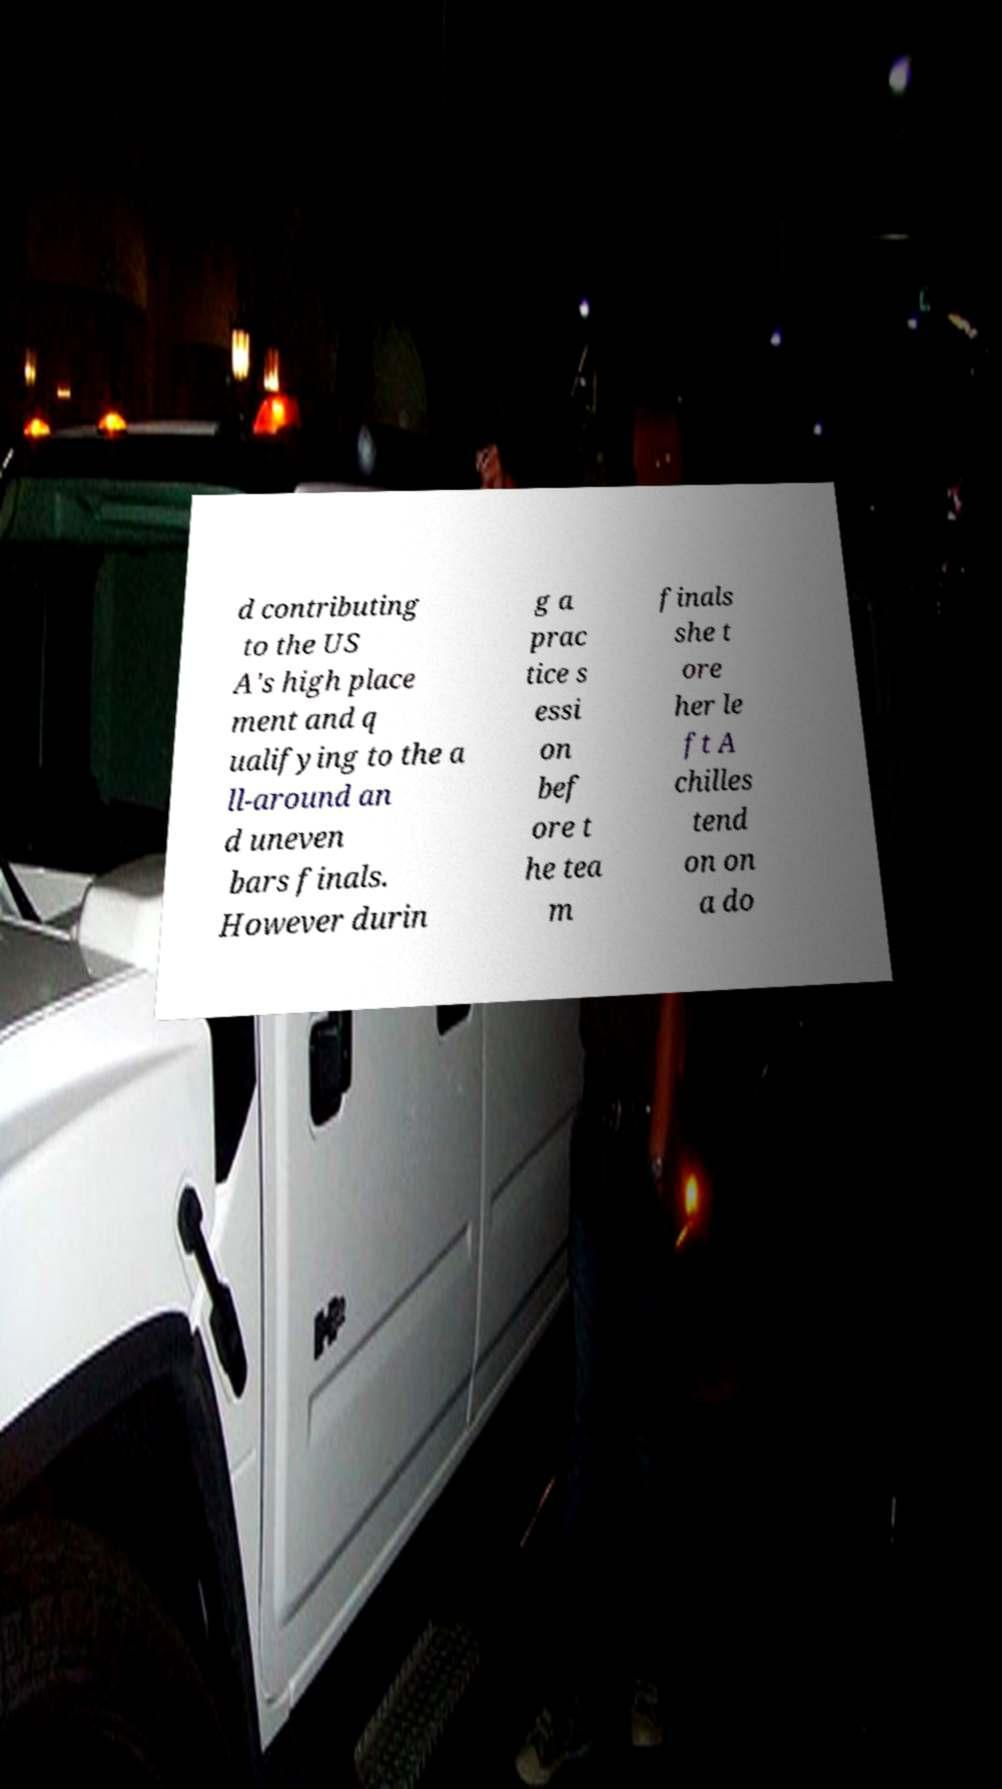I need the written content from this picture converted into text. Can you do that? d contributing to the US A's high place ment and q ualifying to the a ll-around an d uneven bars finals. However durin g a prac tice s essi on bef ore t he tea m finals she t ore her le ft A chilles tend on on a do 